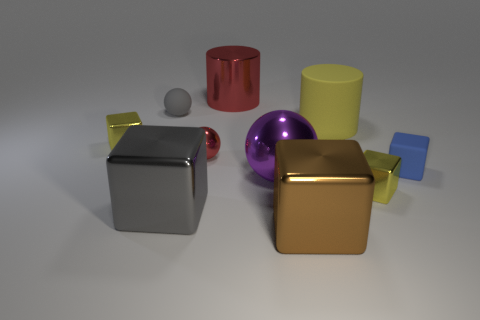Subtract all brown blocks. How many blocks are left? 4 Subtract 2 spheres. How many spheres are left? 1 Subtract all yellow cylinders. How many cylinders are left? 1 Subtract all brown cylinders. How many yellow blocks are left? 2 Subtract all brown metal things. Subtract all small gray balls. How many objects are left? 8 Add 3 large things. How many large things are left? 8 Add 6 small matte balls. How many small matte balls exist? 7 Subtract 0 cyan cylinders. How many objects are left? 10 Subtract all cylinders. How many objects are left? 8 Subtract all gray balls. Subtract all brown cylinders. How many balls are left? 2 